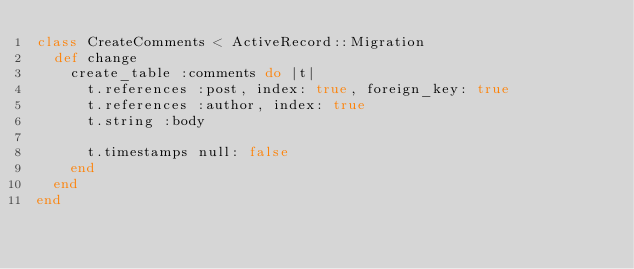Convert code to text. <code><loc_0><loc_0><loc_500><loc_500><_Ruby_>class CreateComments < ActiveRecord::Migration
  def change
    create_table :comments do |t|
      t.references :post, index: true, foreign_key: true
      t.references :author, index: true
      t.string :body

      t.timestamps null: false
    end
  end
end
</code> 